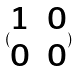<formula> <loc_0><loc_0><loc_500><loc_500>( \begin{matrix} 1 & 0 \\ 0 & 0 \end{matrix} )</formula> 